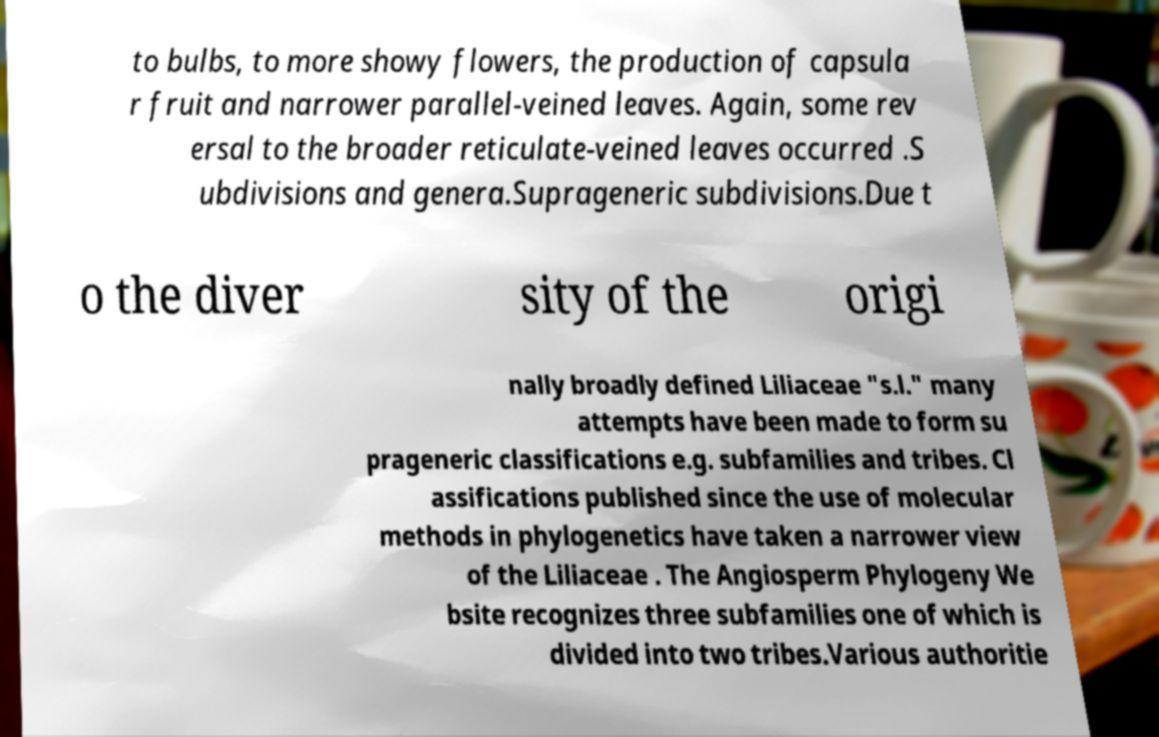Can you accurately transcribe the text from the provided image for me? to bulbs, to more showy flowers, the production of capsula r fruit and narrower parallel-veined leaves. Again, some rev ersal to the broader reticulate-veined leaves occurred .S ubdivisions and genera.Suprageneric subdivisions.Due t o the diver sity of the origi nally broadly defined Liliaceae "s.l." many attempts have been made to form su prageneric classifications e.g. subfamilies and tribes. Cl assifications published since the use of molecular methods in phylogenetics have taken a narrower view of the Liliaceae . The Angiosperm Phylogeny We bsite recognizes three subfamilies one of which is divided into two tribes.Various authoritie 